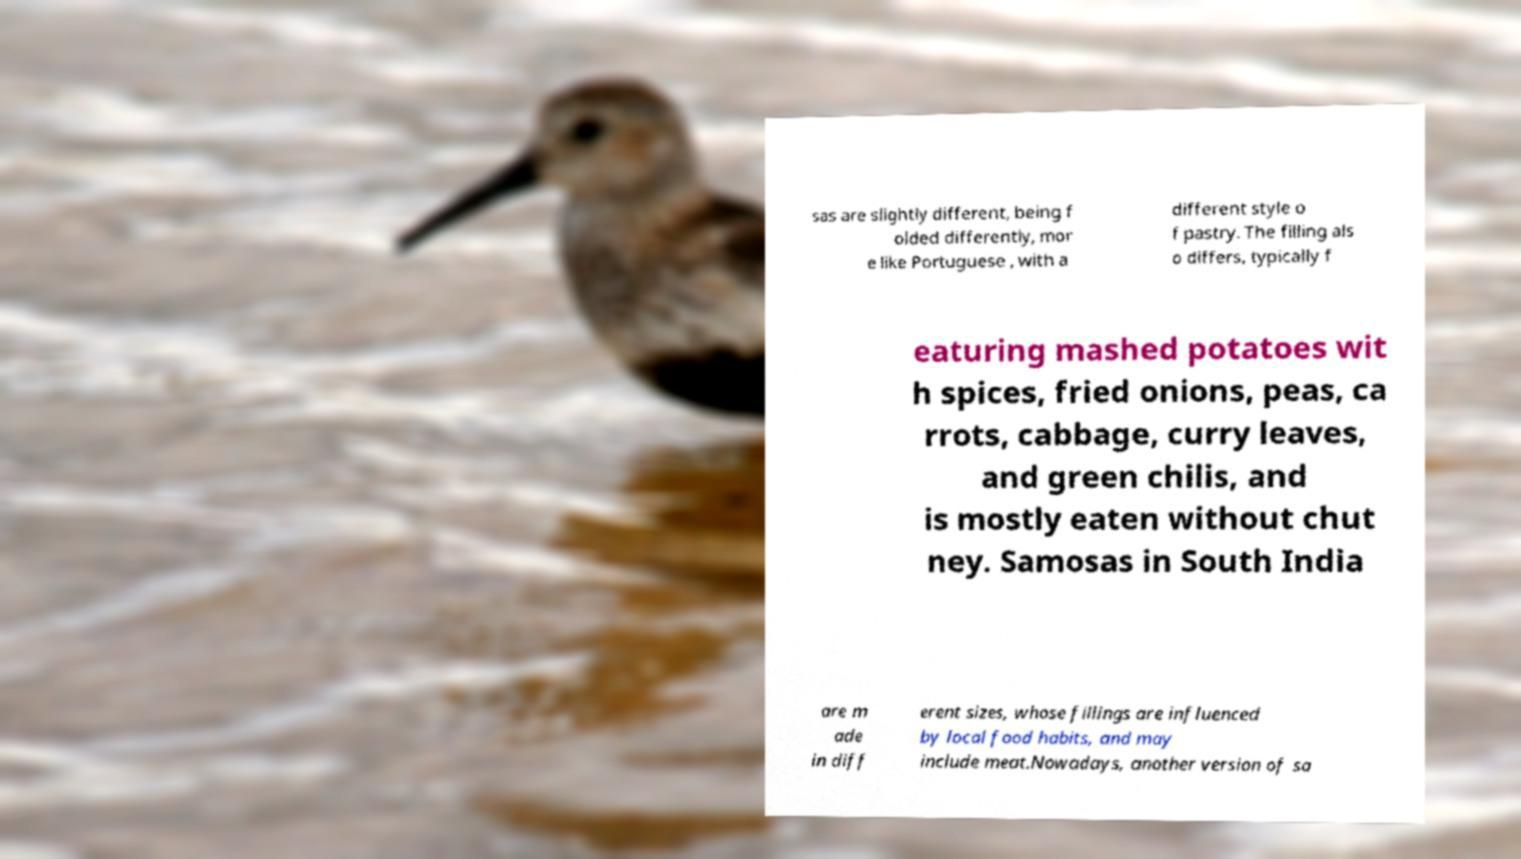Please identify and transcribe the text found in this image. sas are slightly different, being f olded differently, mor e like Portuguese , with a different style o f pastry. The filling als o differs, typically f eaturing mashed potatoes wit h spices, fried onions, peas, ca rrots, cabbage, curry leaves, and green chilis, and is mostly eaten without chut ney. Samosas in South India are m ade in diff erent sizes, whose fillings are influenced by local food habits, and may include meat.Nowadays, another version of sa 